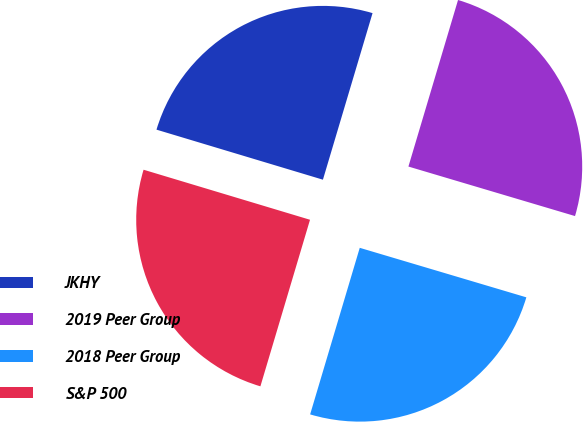<chart> <loc_0><loc_0><loc_500><loc_500><pie_chart><fcel>JKHY<fcel>2019 Peer Group<fcel>2018 Peer Group<fcel>S&P 500<nl><fcel>24.96%<fcel>24.99%<fcel>25.01%<fcel>25.04%<nl></chart> 